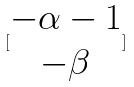<formula> <loc_0><loc_0><loc_500><loc_500>[ \begin{matrix} - \alpha - 1 \\ - \beta \end{matrix} ]</formula> 